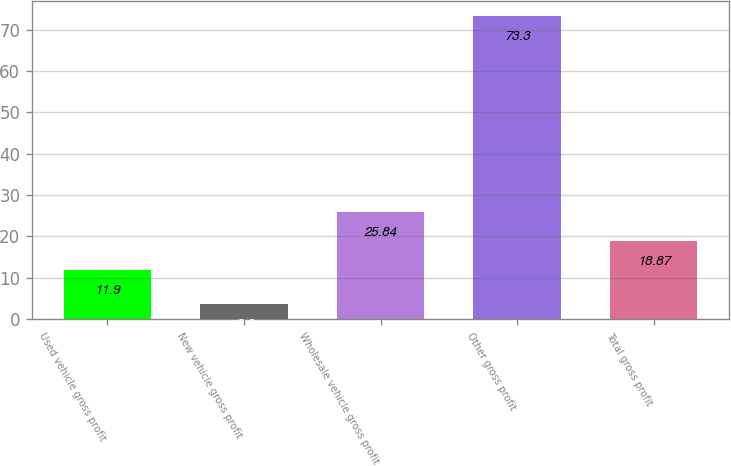<chart> <loc_0><loc_0><loc_500><loc_500><bar_chart><fcel>Used vehicle gross profit<fcel>New vehicle gross profit<fcel>Wholesale vehicle gross profit<fcel>Other gross profit<fcel>Total gross profit<nl><fcel>11.9<fcel>3.6<fcel>25.84<fcel>73.3<fcel>18.87<nl></chart> 